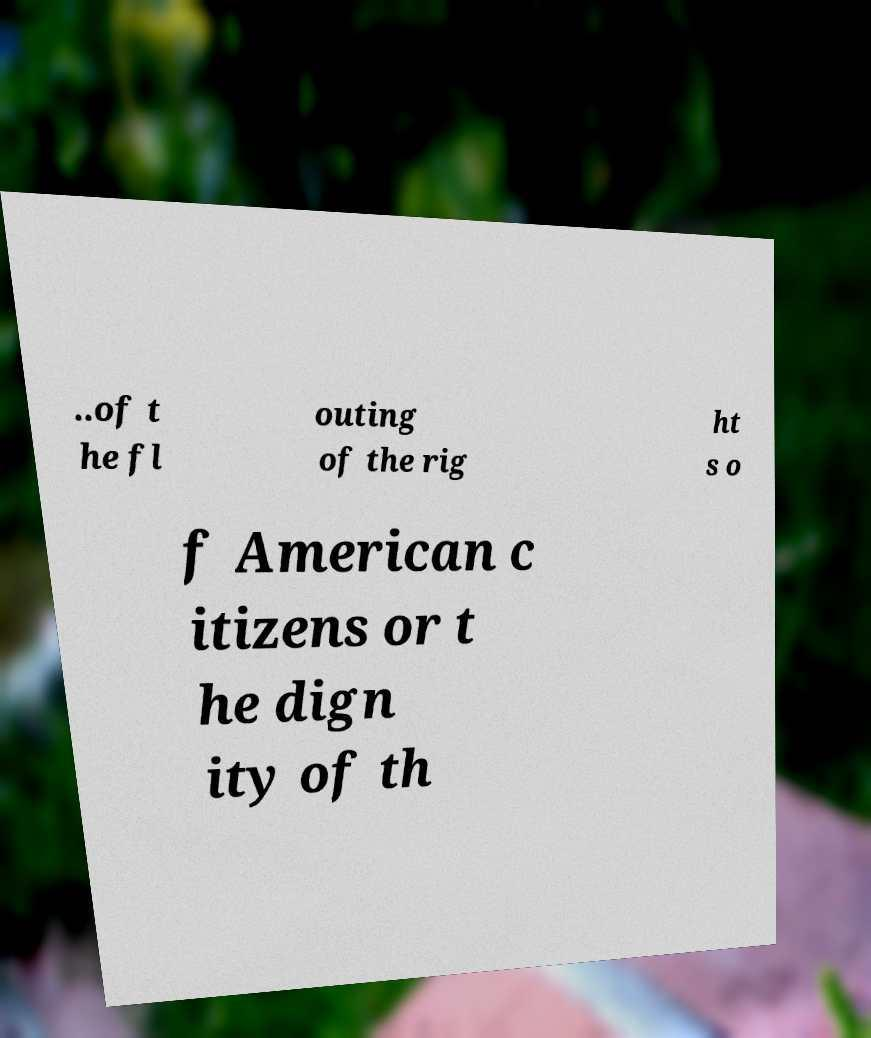For documentation purposes, I need the text within this image transcribed. Could you provide that? ..of t he fl outing of the rig ht s o f American c itizens or t he dign ity of th 